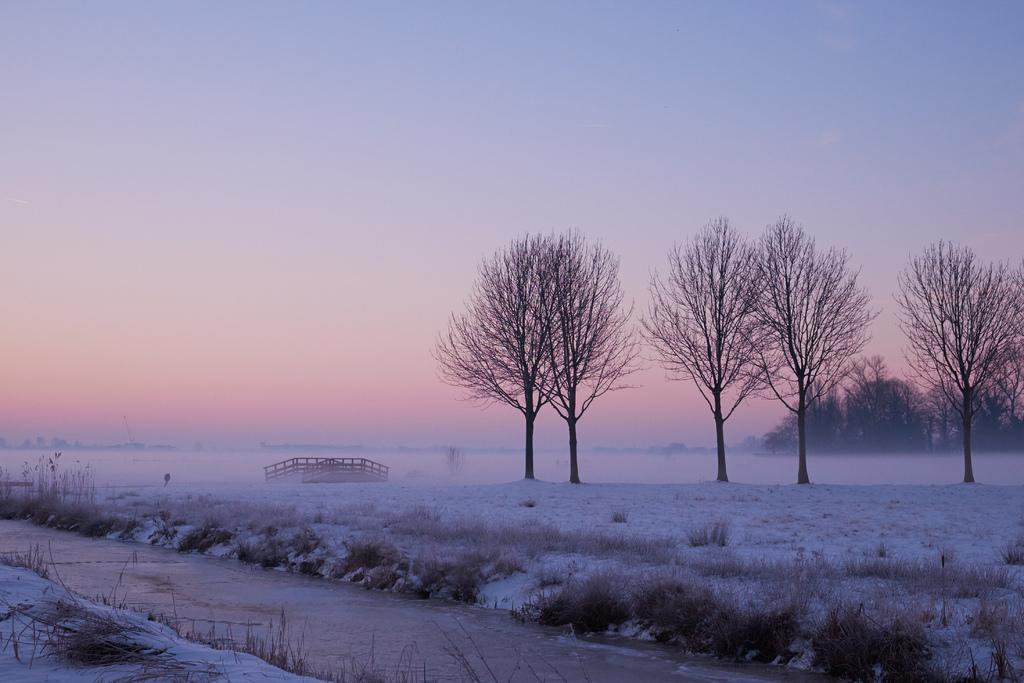What type of vegetation is present in the image? There are trees and grass in the image. What is the ground covered with in the image? The ground is covered with grass, plants, a walkway, and snow. What can be seen in the sky in the image? The sky is visible at the top of the image. What other objects are present in the image besides vegetation and the sky? There are other objects in the image, but their specific details are not mentioned in the provided facts. What answer is given by the person in the image? There is no person present in the image, so no answer can be given. How does the person in the image say good-bye? There is no person present in the image, so there is no good-bye to be observed. 